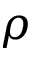<formula> <loc_0><loc_0><loc_500><loc_500>\rho</formula> 